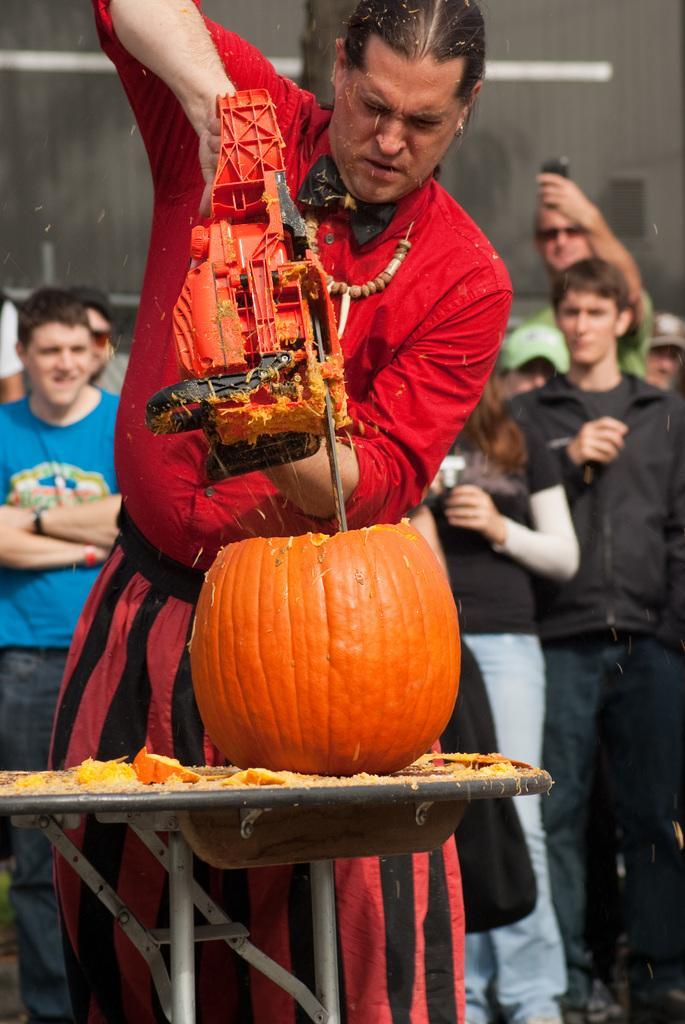Can you describe this image briefly? In this picture there is a person standing behind the table and drilling the pumpkin. There is a pumpkin on the table. At the back there are group of people standing and there is a person with green t-shirt is standing and holding the phone. 